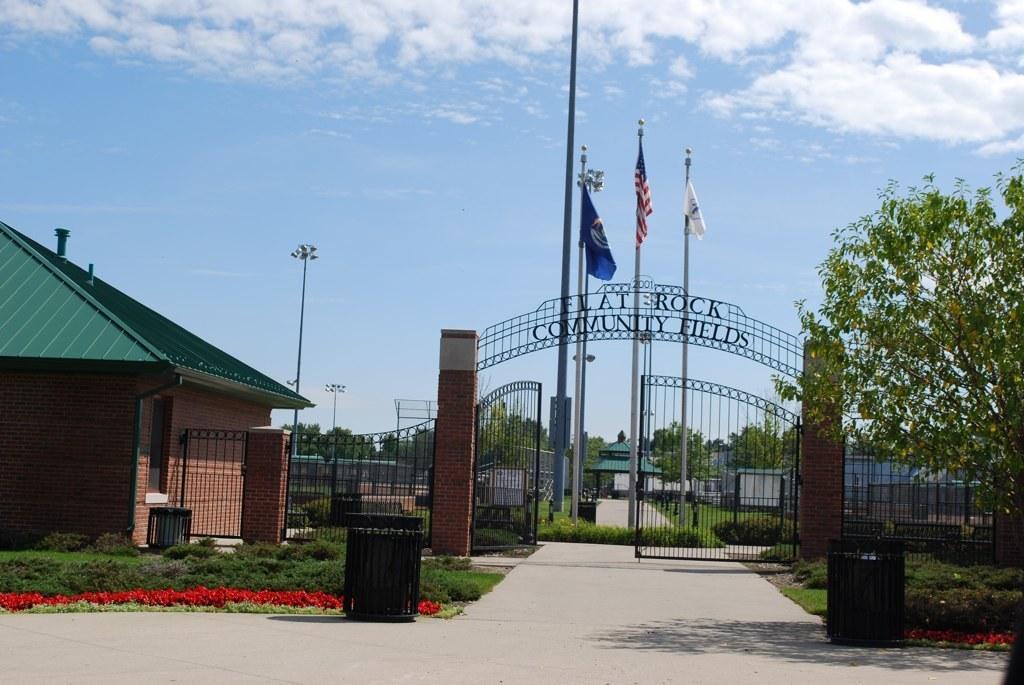How would you summarize this image in a sentence or two? In the picture I can see flags, buildings, trees, gates and a fence. In the background I can see pole lights, the grass, a road, the sky and some other objects on the ground. 